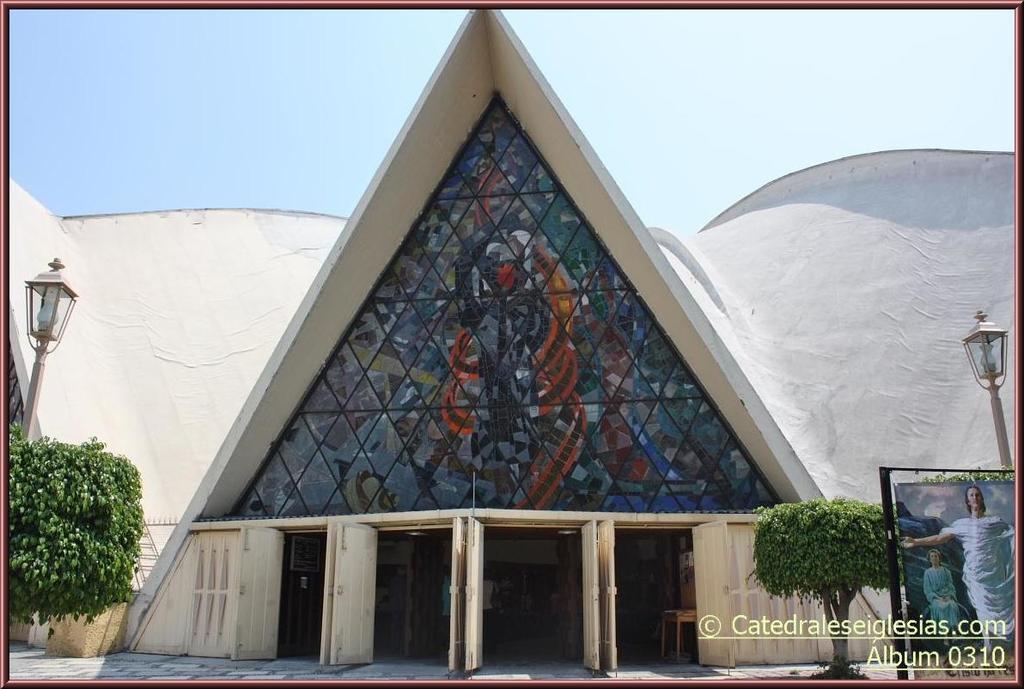In one or two sentences, can you explain what this image depicts? In the image there is a building which is in triangle shape and also there are glasses and doors. On the left and right corner of the image there are poles with lamps and also there are trees. On the right side of the image there is a poster with images. In the right bottom corner of the image there is a name. At the top of the image there is a sky. 